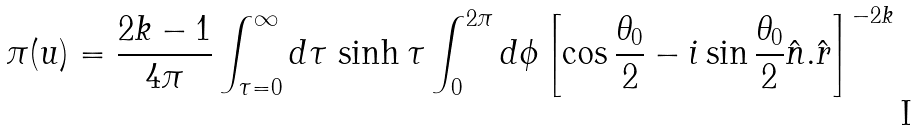Convert formula to latex. <formula><loc_0><loc_0><loc_500><loc_500>\pi ( u ) = \frac { 2 k - 1 } { 4 \pi } \int _ { \tau = 0 } ^ { \infty } d \tau \, \sinh \tau \int _ { 0 } ^ { 2 \pi } d \phi \left [ \cos \frac { \theta _ { 0 } } { 2 } - i \sin \frac { \theta _ { 0 } } { 2 } \hat { n } . \hat { r } \right ] ^ { - 2 k }</formula> 